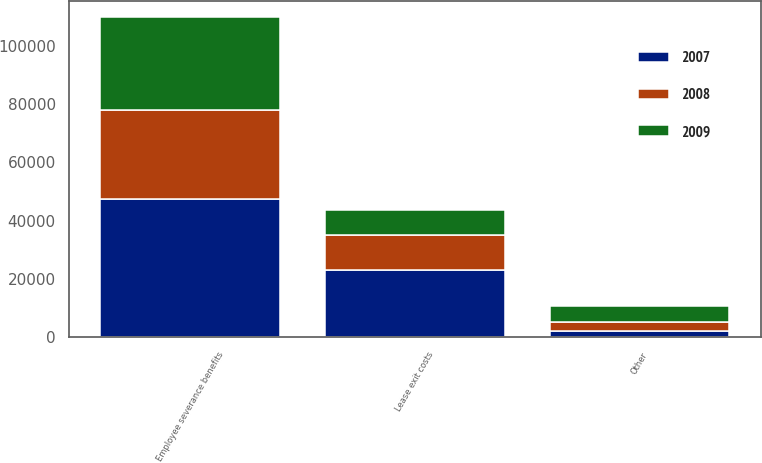Convert chart to OTSL. <chart><loc_0><loc_0><loc_500><loc_500><stacked_bar_chart><ecel><fcel>Employee severance benefits<fcel>Lease exit costs<fcel>Other<nl><fcel>2007<fcel>47525<fcel>23208<fcel>2283<nl><fcel>2008<fcel>30343<fcel>12095<fcel>3069<nl><fcel>2009<fcel>32023<fcel>8320<fcel>5362<nl></chart> 